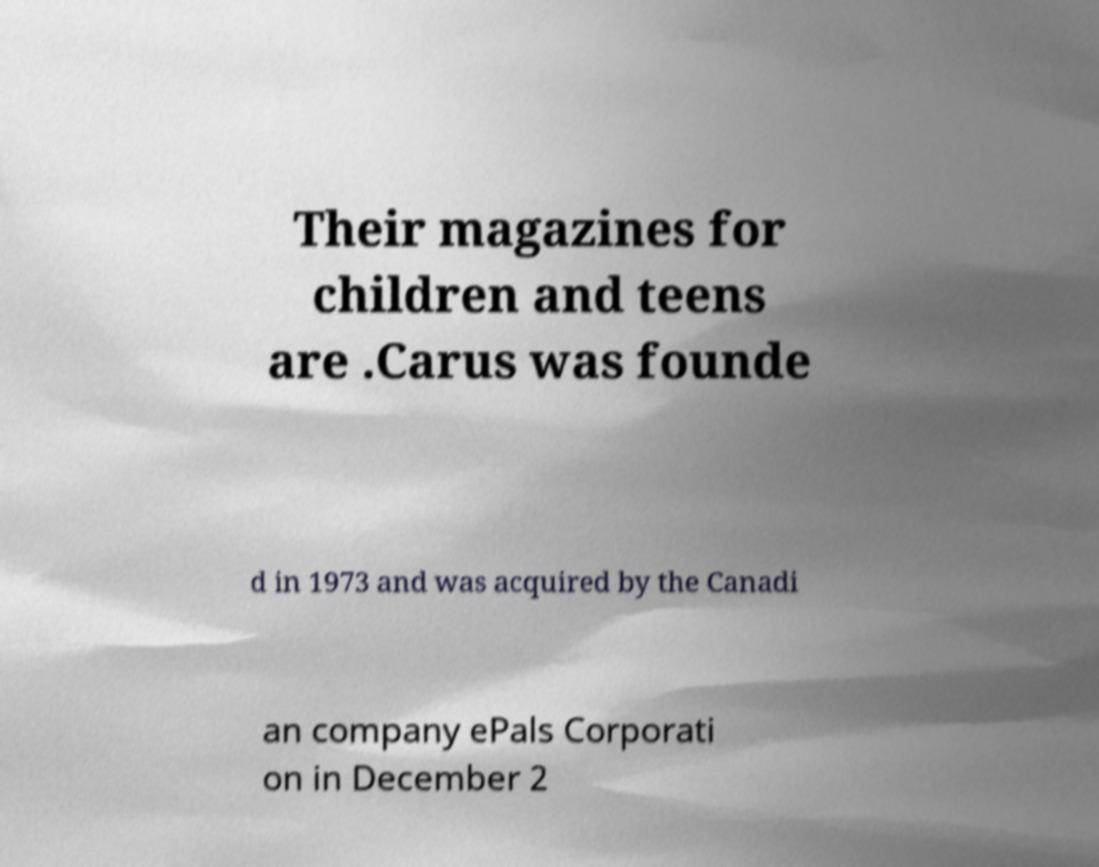Can you accurately transcribe the text from the provided image for me? Their magazines for children and teens are .Carus was founde d in 1973 and was acquired by the Canadi an company ePals Corporati on in December 2 